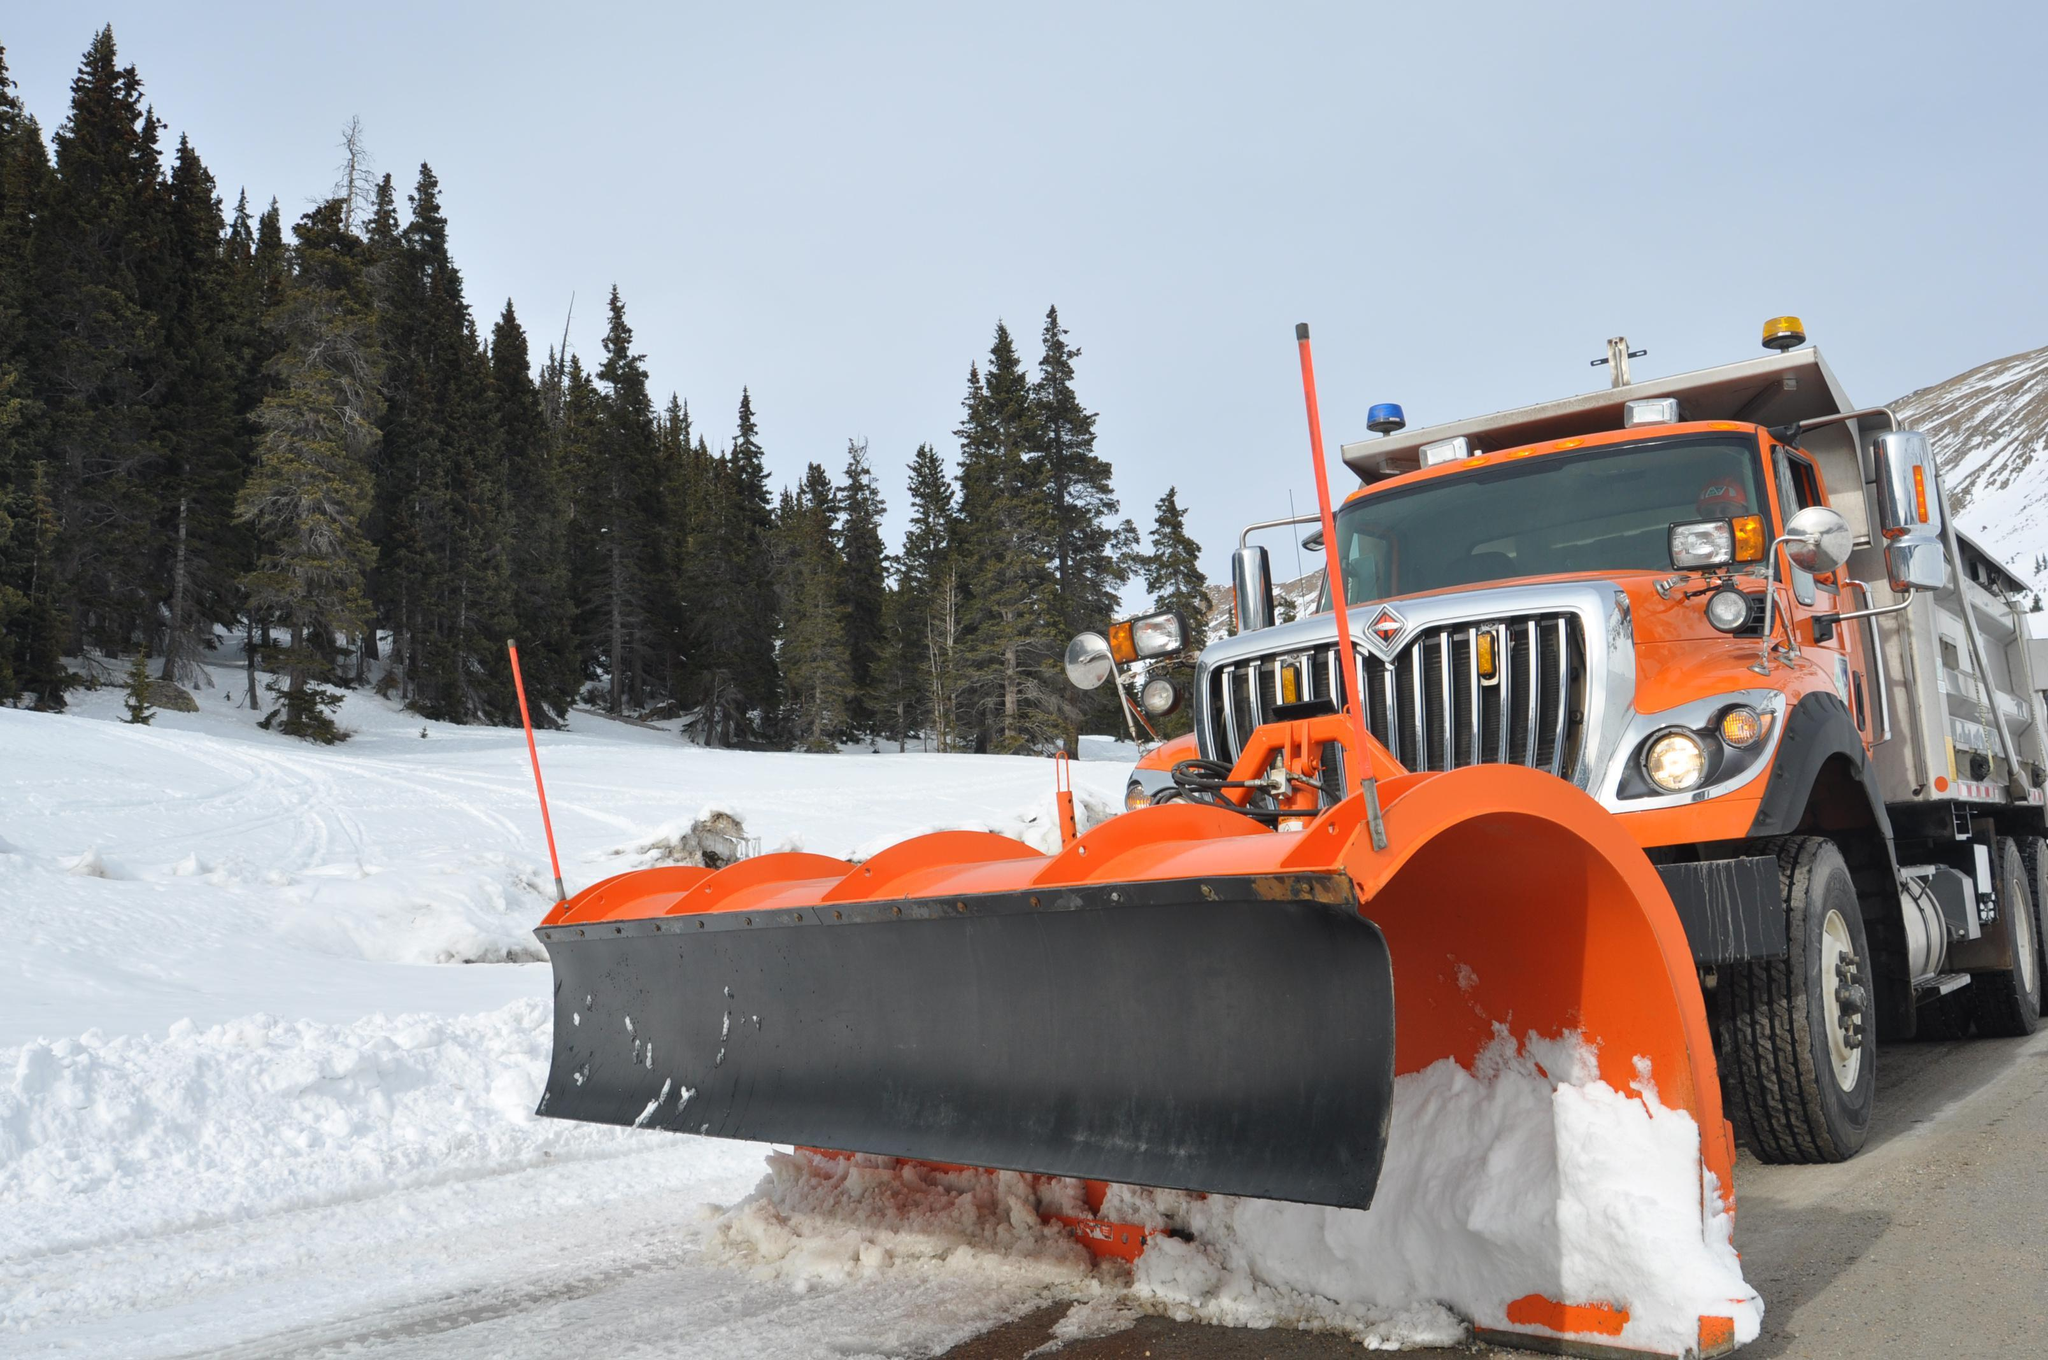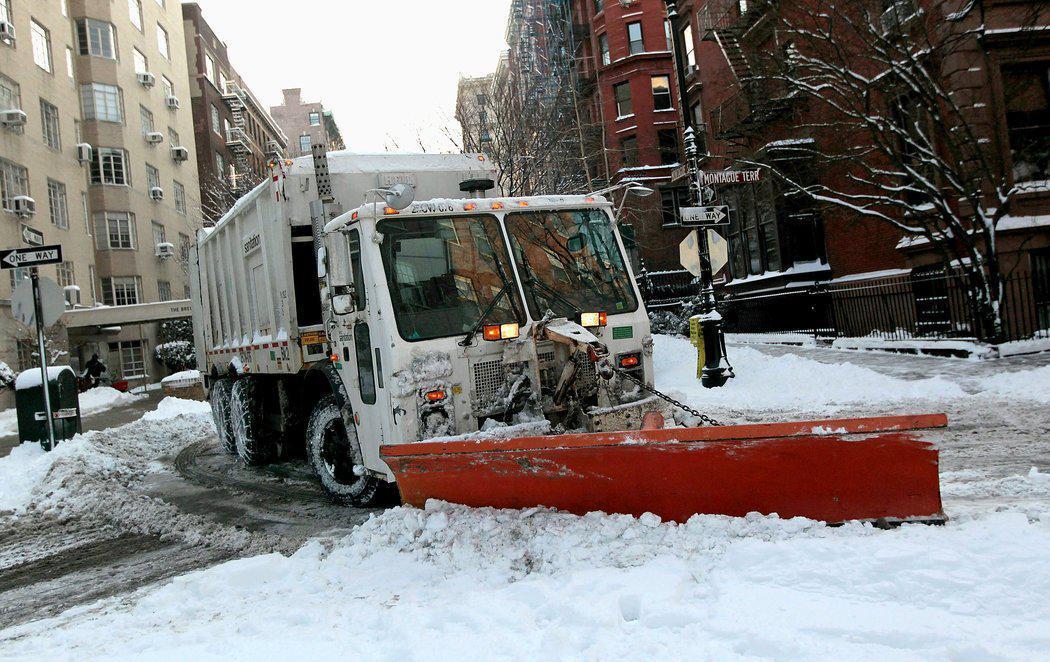The first image is the image on the left, the second image is the image on the right. Analyze the images presented: Is the assertion "Both plows are attached to large trucks and have visible snow on them." valid? Answer yes or no. Yes. The first image is the image on the left, the second image is the image on the right. Assess this claim about the two images: "The left and right image contains the same number of snow dump trunks.". Correct or not? Answer yes or no. Yes. 